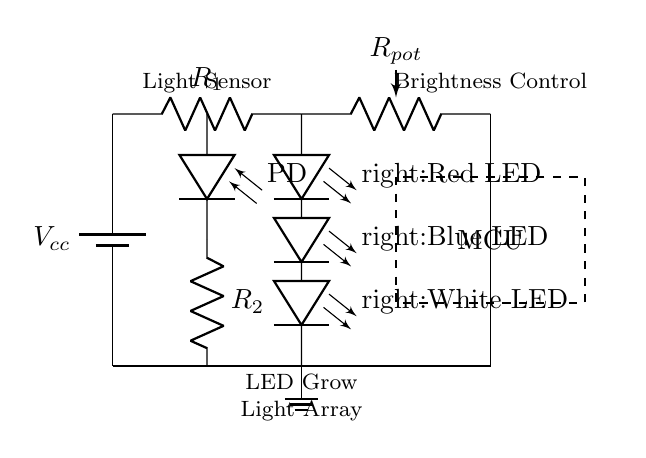What type of LEDs are used in the array? The circuit diagram shows three LED types labeled as Red, Blue, and White, indicating their respective colors.
Answer: Red, Blue, White What component is used for brightness control? The potentiometer labeled as R_pot is specifically designated for controlling the brightness of the LED grow light by varying the resistance in the circuit.
Answer: R_pot How many resistors are present in the circuit? There are two resistors shown in the circuit, R_1 for current limiting and R_2 connected with the photodiode.
Answer: 2 What is the function of the photodiode in this circuit? The photodiode detects light levels; when it senses insufficient light, it triggers the microcontroller to turn on the LED grow lights as needed.
Answer: Light sensor Explain the connection between the microcontroller and the photodiode. The photodiode is connected to the microcontroller through resistor R_2. When light intensity varies, the photodiode generates a voltage that the microcontroller can read, enabling it to control the LED's operation accordingly.
Answer: Enables light detection What role does the current limiting resistor R_1 serve in this circuit? The current limiting resistor R_1 prevents excessive current from flowing through the LED array, protecting the LEDs from damage while ensuring they operate within their rated current specifications.
Answer: Current protection What is the purpose of the battery labeled as V_cc? The battery provides the necessary voltage supply for the entire circuit, ensuring that all components, including the LEDs and the microcontroller, receive adequate power to function correctly.
Answer: Power supply 